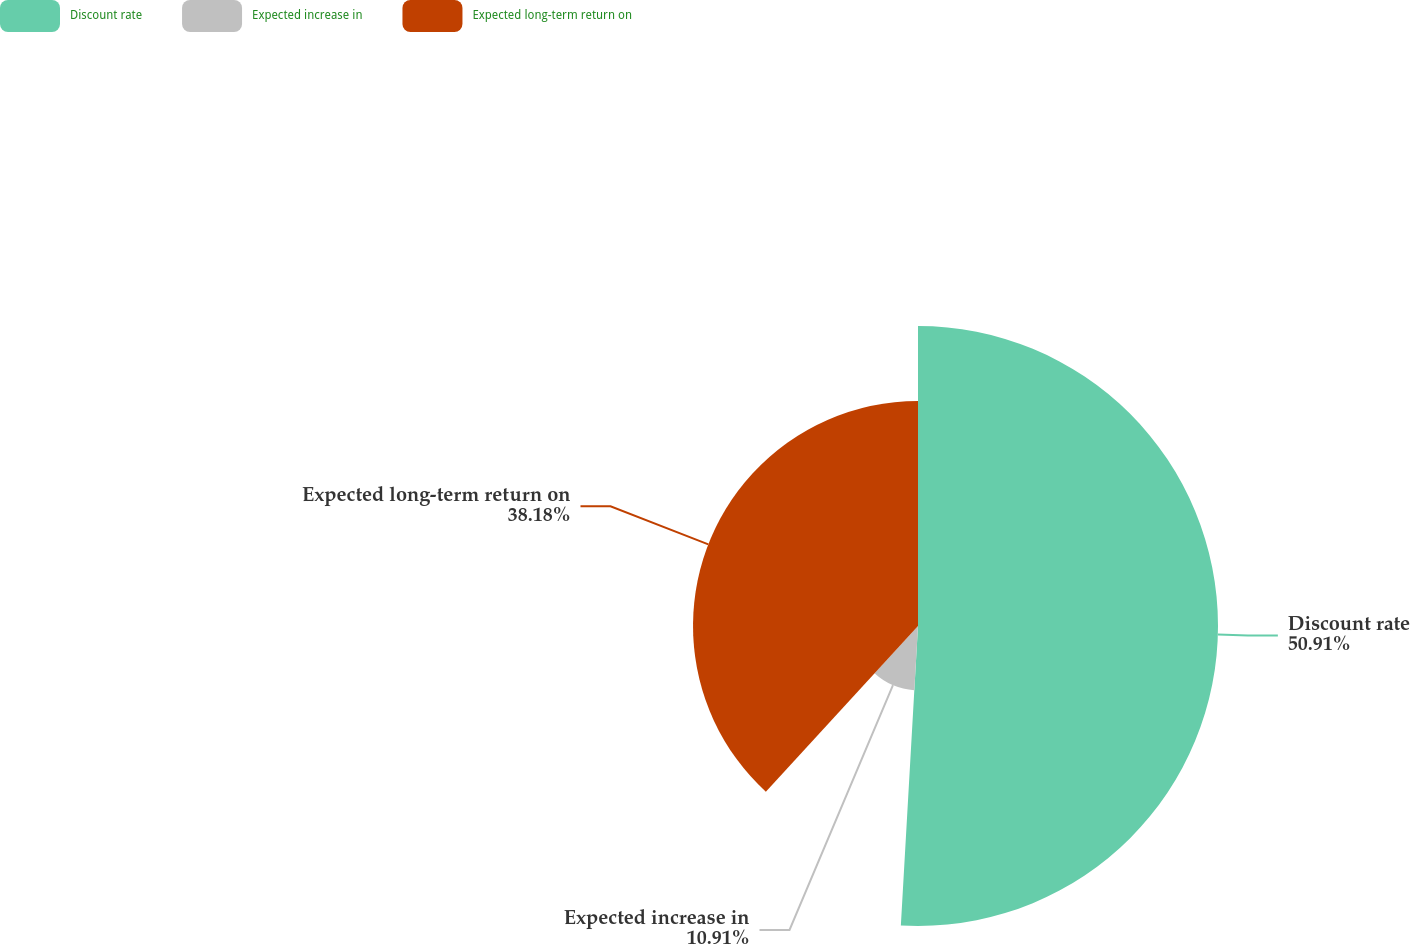<chart> <loc_0><loc_0><loc_500><loc_500><pie_chart><fcel>Discount rate<fcel>Expected increase in<fcel>Expected long-term return on<nl><fcel>50.91%<fcel>10.91%<fcel>38.18%<nl></chart> 